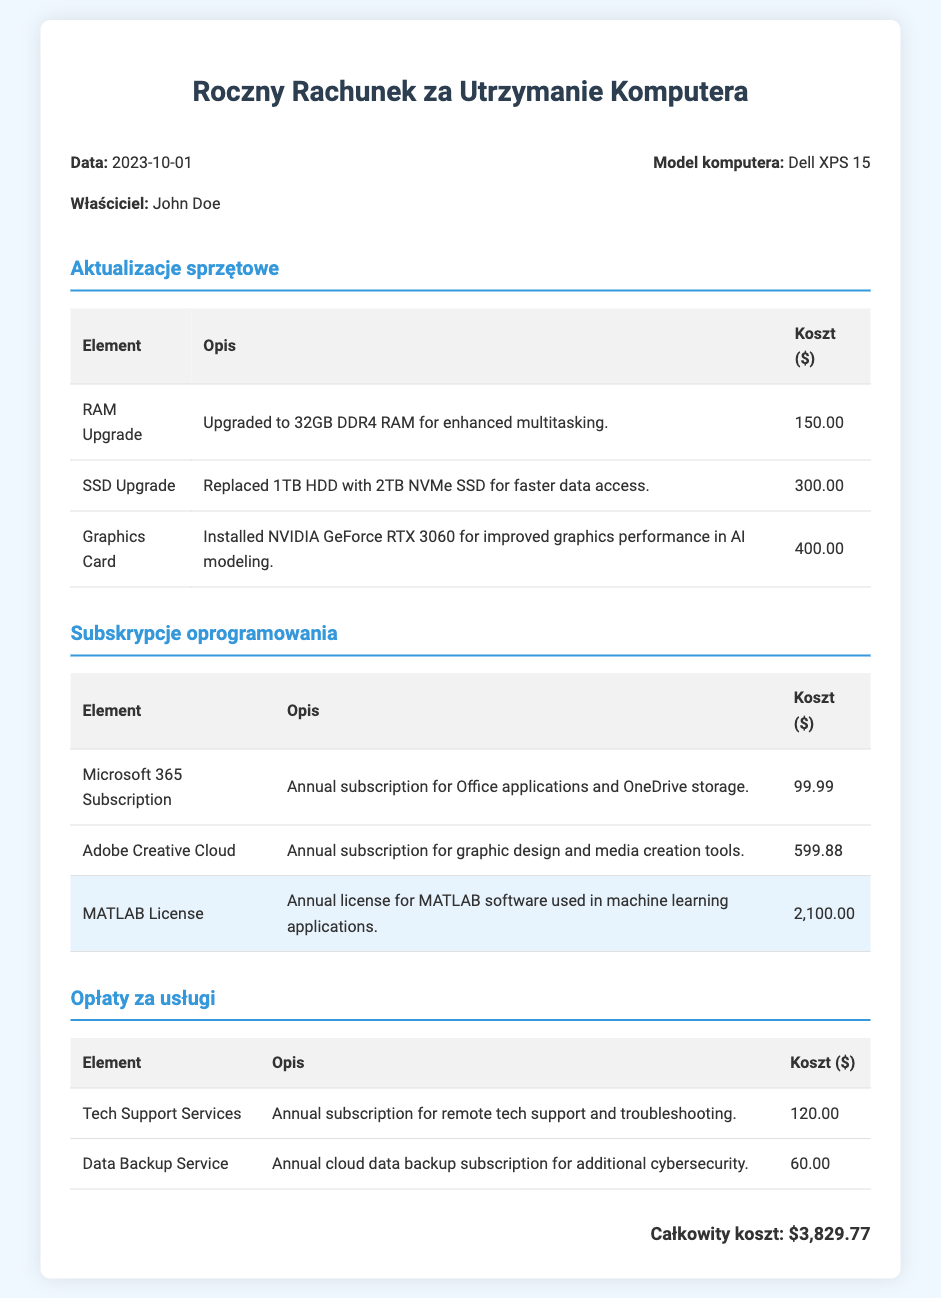What is the date of the bill? The date of the bill is stated in the document, which is specified as 2023-10-01.
Answer: 2023-10-01 Who is the owner of the computer? The document lists the owner's name, which is John Doe.
Answer: John Doe What is the model of the computer? The model of the computer is found in the bill and is specified as Dell XPS 15.
Answer: Dell XPS 15 What is the total cost of hardware upgrades? The costs of individual hardware upgrades total to $150.00 + $300.00 + $400.00, which sums up to $850.00.
Answer: $850.00 How much does the MATLAB license cost? The document explicitly lists the cost of the MATLAB license, which is $2,100.00.
Answer: $2,100.00 Which software subscription has the highest cost? By comparing the software subscriptions, the MATLAB License at $2,100.00 is identified as having the highest cost.
Answer: MATLAB License What is the cost for Tech Support Services? The cost of Tech Support Services is provided in the service fees and is stated as $120.00.
Answer: $120.00 What is the total cost of the annual maintenance bill? The total cost is summarized at the end of the document, totaling all expenses to $3,829.77.
Answer: $3,829.77 